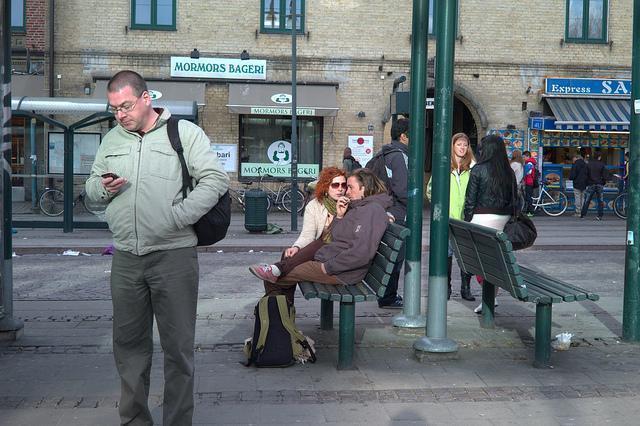What type of shop is the one with the woman's picture in a circle on the window?
Indicate the correct choice and explain in the format: 'Answer: answer
Rationale: rationale.'
Options: Bakery, bookstore, music shop, women's clothing. Answer: bakery.
Rationale: This is swedish for "bakery". 